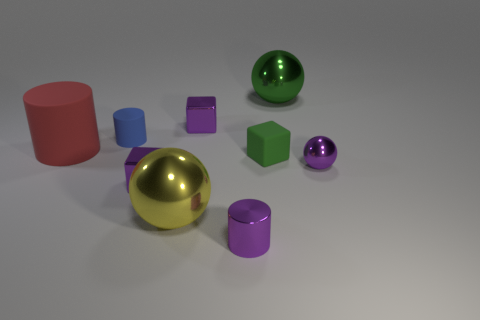Add 1 small purple rubber spheres. How many objects exist? 10 Subtract all cylinders. How many objects are left? 6 Subtract 1 red cylinders. How many objects are left? 8 Subtract all tiny red objects. Subtract all blue cylinders. How many objects are left? 8 Add 6 purple cylinders. How many purple cylinders are left? 7 Add 2 tiny purple metal objects. How many tiny purple metal objects exist? 6 